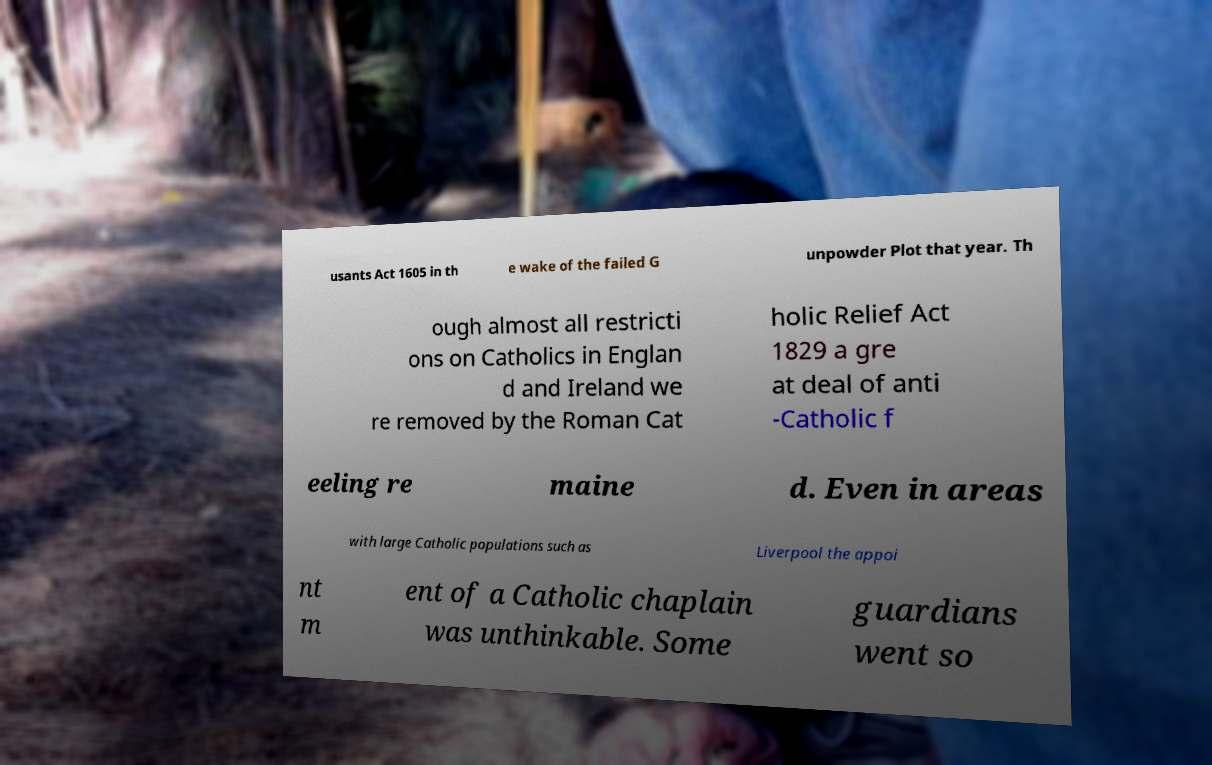Can you accurately transcribe the text from the provided image for me? usants Act 1605 in th e wake of the failed G unpowder Plot that year. Th ough almost all restricti ons on Catholics in Englan d and Ireland we re removed by the Roman Cat holic Relief Act 1829 a gre at deal of anti -Catholic f eeling re maine d. Even in areas with large Catholic populations such as Liverpool the appoi nt m ent of a Catholic chaplain was unthinkable. Some guardians went so 